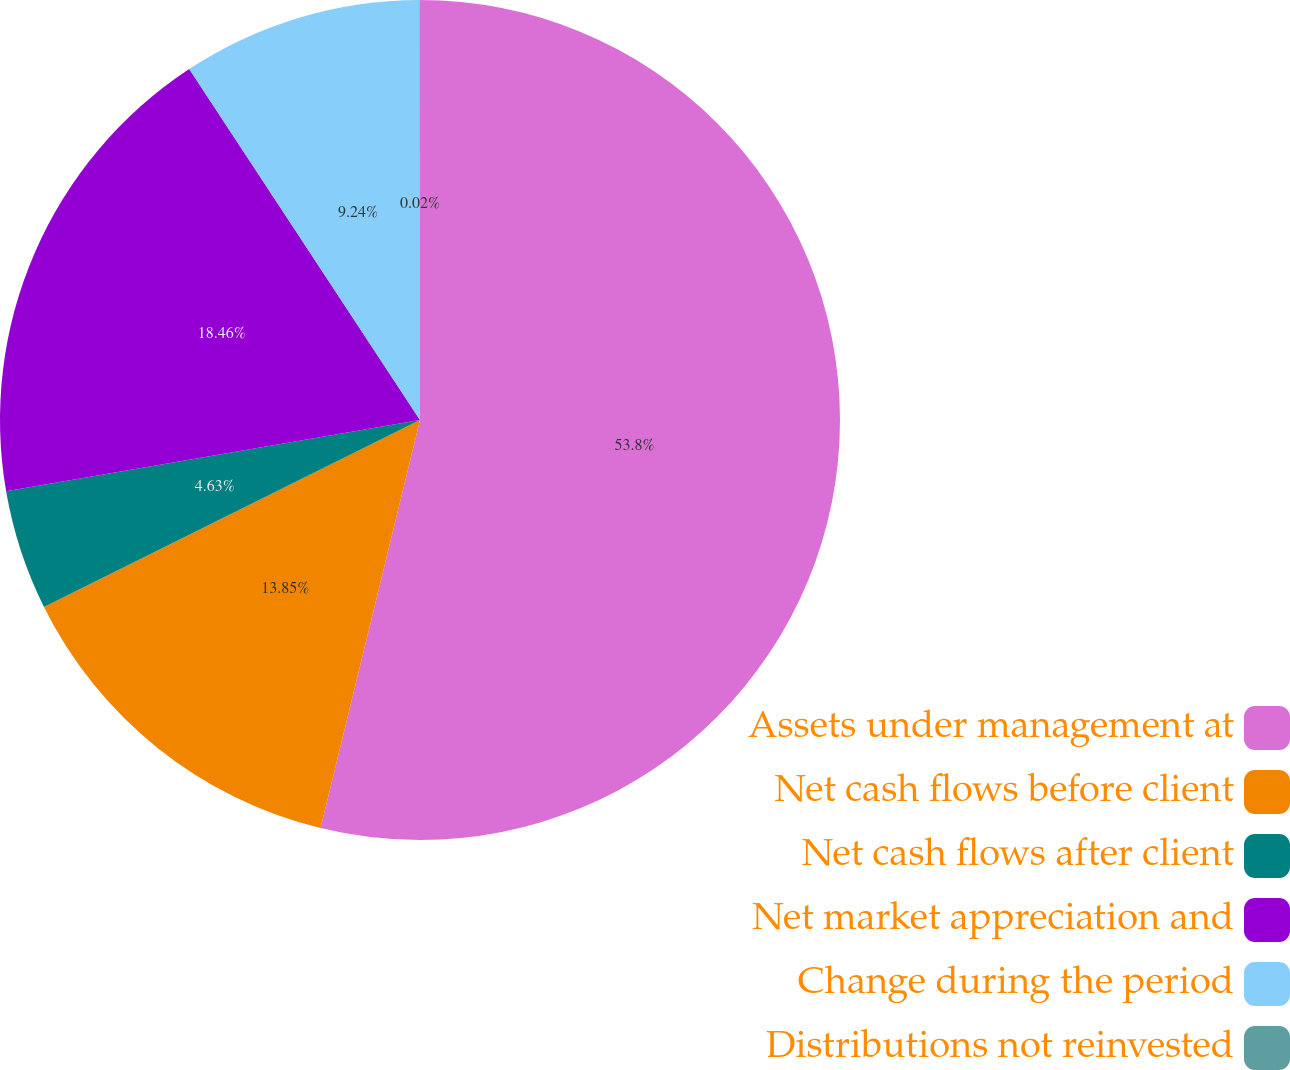Convert chart. <chart><loc_0><loc_0><loc_500><loc_500><pie_chart><fcel>Assets under management at<fcel>Net cash flows before client<fcel>Net cash flows after client<fcel>Net market appreciation and<fcel>Change during the period<fcel>Distributions not reinvested<nl><fcel>53.81%<fcel>13.85%<fcel>4.63%<fcel>18.46%<fcel>9.24%<fcel>0.02%<nl></chart> 